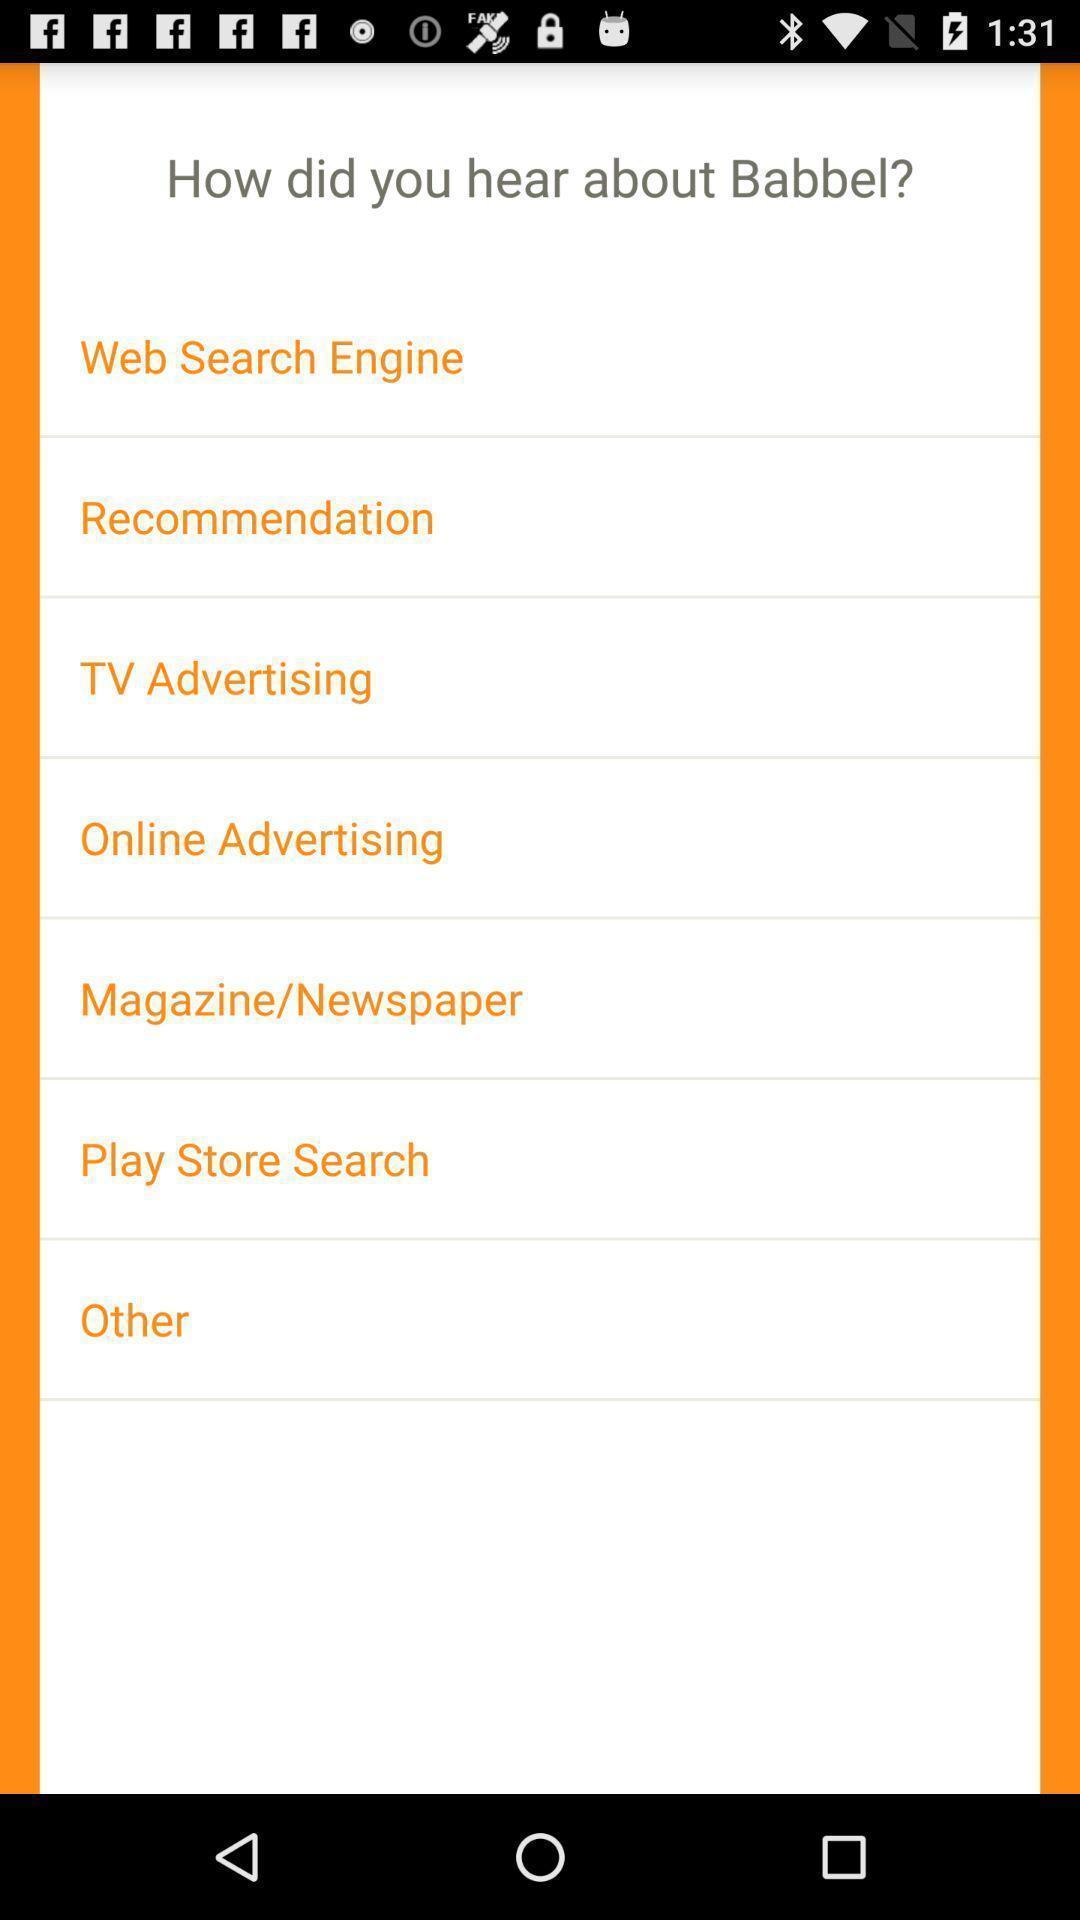Provide a textual representation of this image. Screen shows multiple options. 